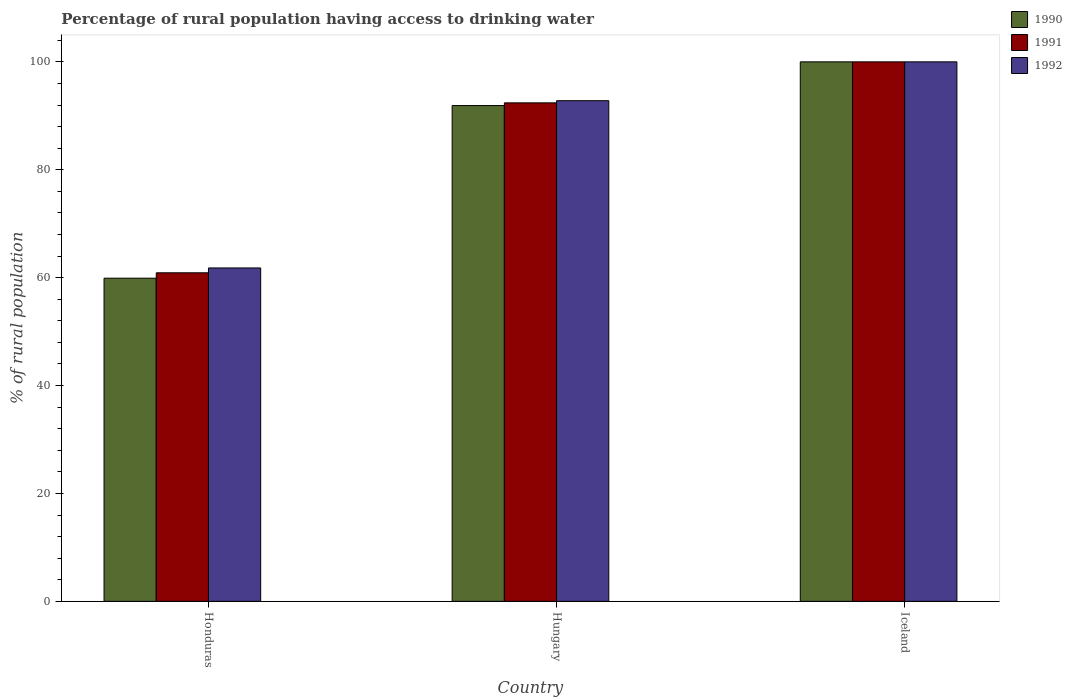How many different coloured bars are there?
Provide a succinct answer. 3. Are the number of bars per tick equal to the number of legend labels?
Offer a terse response. Yes. Are the number of bars on each tick of the X-axis equal?
Make the answer very short. Yes. How many bars are there on the 3rd tick from the left?
Your answer should be compact. 3. How many bars are there on the 1st tick from the right?
Give a very brief answer. 3. What is the label of the 1st group of bars from the left?
Keep it short and to the point. Honduras. What is the percentage of rural population having access to drinking water in 1991 in Honduras?
Offer a very short reply. 60.9. Across all countries, what is the maximum percentage of rural population having access to drinking water in 1991?
Your answer should be compact. 100. Across all countries, what is the minimum percentage of rural population having access to drinking water in 1992?
Provide a short and direct response. 61.8. In which country was the percentage of rural population having access to drinking water in 1992 minimum?
Give a very brief answer. Honduras. What is the total percentage of rural population having access to drinking water in 1990 in the graph?
Provide a short and direct response. 251.8. What is the difference between the percentage of rural population having access to drinking water in 1990 in Honduras and that in Iceland?
Keep it short and to the point. -40.1. What is the difference between the percentage of rural population having access to drinking water in 1992 in Iceland and the percentage of rural population having access to drinking water in 1991 in Hungary?
Make the answer very short. 7.6. What is the average percentage of rural population having access to drinking water in 1992 per country?
Your answer should be very brief. 84.87. What is the ratio of the percentage of rural population having access to drinking water in 1992 in Hungary to that in Iceland?
Your answer should be compact. 0.93. What is the difference between the highest and the second highest percentage of rural population having access to drinking water in 1991?
Give a very brief answer. 39.1. What is the difference between the highest and the lowest percentage of rural population having access to drinking water in 1991?
Offer a terse response. 39.1. Is the sum of the percentage of rural population having access to drinking water in 1990 in Honduras and Iceland greater than the maximum percentage of rural population having access to drinking water in 1991 across all countries?
Make the answer very short. Yes. What does the 3rd bar from the right in Honduras represents?
Your response must be concise. 1990. How many bars are there?
Your answer should be compact. 9. How many countries are there in the graph?
Your answer should be very brief. 3. Does the graph contain any zero values?
Offer a terse response. No. Does the graph contain grids?
Give a very brief answer. No. Where does the legend appear in the graph?
Your response must be concise. Top right. What is the title of the graph?
Keep it short and to the point. Percentage of rural population having access to drinking water. Does "2003" appear as one of the legend labels in the graph?
Your answer should be very brief. No. What is the label or title of the X-axis?
Keep it short and to the point. Country. What is the label or title of the Y-axis?
Provide a short and direct response. % of rural population. What is the % of rural population in 1990 in Honduras?
Keep it short and to the point. 59.9. What is the % of rural population in 1991 in Honduras?
Offer a very short reply. 60.9. What is the % of rural population of 1992 in Honduras?
Your answer should be very brief. 61.8. What is the % of rural population of 1990 in Hungary?
Make the answer very short. 91.9. What is the % of rural population of 1991 in Hungary?
Offer a very short reply. 92.4. What is the % of rural population in 1992 in Hungary?
Your answer should be very brief. 92.8. What is the % of rural population in 1990 in Iceland?
Provide a short and direct response. 100. What is the % of rural population of 1992 in Iceland?
Offer a terse response. 100. Across all countries, what is the maximum % of rural population of 1991?
Make the answer very short. 100. Across all countries, what is the minimum % of rural population in 1990?
Offer a terse response. 59.9. Across all countries, what is the minimum % of rural population of 1991?
Offer a terse response. 60.9. Across all countries, what is the minimum % of rural population of 1992?
Offer a terse response. 61.8. What is the total % of rural population in 1990 in the graph?
Offer a very short reply. 251.8. What is the total % of rural population of 1991 in the graph?
Your answer should be compact. 253.3. What is the total % of rural population of 1992 in the graph?
Offer a terse response. 254.6. What is the difference between the % of rural population of 1990 in Honduras and that in Hungary?
Give a very brief answer. -32. What is the difference between the % of rural population of 1991 in Honduras and that in Hungary?
Provide a succinct answer. -31.5. What is the difference between the % of rural population of 1992 in Honduras and that in Hungary?
Provide a succinct answer. -31. What is the difference between the % of rural population of 1990 in Honduras and that in Iceland?
Offer a very short reply. -40.1. What is the difference between the % of rural population of 1991 in Honduras and that in Iceland?
Give a very brief answer. -39.1. What is the difference between the % of rural population in 1992 in Honduras and that in Iceland?
Your answer should be very brief. -38.2. What is the difference between the % of rural population in 1990 in Hungary and that in Iceland?
Offer a very short reply. -8.1. What is the difference between the % of rural population of 1992 in Hungary and that in Iceland?
Your answer should be very brief. -7.2. What is the difference between the % of rural population in 1990 in Honduras and the % of rural population in 1991 in Hungary?
Provide a short and direct response. -32.5. What is the difference between the % of rural population in 1990 in Honduras and the % of rural population in 1992 in Hungary?
Give a very brief answer. -32.9. What is the difference between the % of rural population of 1991 in Honduras and the % of rural population of 1992 in Hungary?
Your response must be concise. -31.9. What is the difference between the % of rural population of 1990 in Honduras and the % of rural population of 1991 in Iceland?
Your response must be concise. -40.1. What is the difference between the % of rural population in 1990 in Honduras and the % of rural population in 1992 in Iceland?
Provide a succinct answer. -40.1. What is the difference between the % of rural population of 1991 in Honduras and the % of rural population of 1992 in Iceland?
Make the answer very short. -39.1. What is the difference between the % of rural population of 1990 in Hungary and the % of rural population of 1991 in Iceland?
Offer a very short reply. -8.1. What is the difference between the % of rural population in 1990 in Hungary and the % of rural population in 1992 in Iceland?
Give a very brief answer. -8.1. What is the difference between the % of rural population in 1991 in Hungary and the % of rural population in 1992 in Iceland?
Your response must be concise. -7.6. What is the average % of rural population of 1990 per country?
Give a very brief answer. 83.93. What is the average % of rural population in 1991 per country?
Offer a very short reply. 84.43. What is the average % of rural population in 1992 per country?
Ensure brevity in your answer.  84.87. What is the difference between the % of rural population in 1990 and % of rural population in 1991 in Honduras?
Offer a terse response. -1. What is the difference between the % of rural population of 1991 and % of rural population of 1992 in Hungary?
Keep it short and to the point. -0.4. What is the difference between the % of rural population in 1990 and % of rural population in 1992 in Iceland?
Provide a succinct answer. 0. What is the ratio of the % of rural population in 1990 in Honduras to that in Hungary?
Ensure brevity in your answer.  0.65. What is the ratio of the % of rural population of 1991 in Honduras to that in Hungary?
Your answer should be very brief. 0.66. What is the ratio of the % of rural population in 1992 in Honduras to that in Hungary?
Offer a terse response. 0.67. What is the ratio of the % of rural population in 1990 in Honduras to that in Iceland?
Ensure brevity in your answer.  0.6. What is the ratio of the % of rural population of 1991 in Honduras to that in Iceland?
Provide a short and direct response. 0.61. What is the ratio of the % of rural population of 1992 in Honduras to that in Iceland?
Provide a succinct answer. 0.62. What is the ratio of the % of rural population of 1990 in Hungary to that in Iceland?
Your response must be concise. 0.92. What is the ratio of the % of rural population of 1991 in Hungary to that in Iceland?
Provide a succinct answer. 0.92. What is the ratio of the % of rural population in 1992 in Hungary to that in Iceland?
Keep it short and to the point. 0.93. What is the difference between the highest and the second highest % of rural population of 1990?
Your answer should be very brief. 8.1. What is the difference between the highest and the second highest % of rural population of 1991?
Your answer should be compact. 7.6. What is the difference between the highest and the second highest % of rural population in 1992?
Offer a very short reply. 7.2. What is the difference between the highest and the lowest % of rural population of 1990?
Your answer should be very brief. 40.1. What is the difference between the highest and the lowest % of rural population in 1991?
Ensure brevity in your answer.  39.1. What is the difference between the highest and the lowest % of rural population of 1992?
Keep it short and to the point. 38.2. 